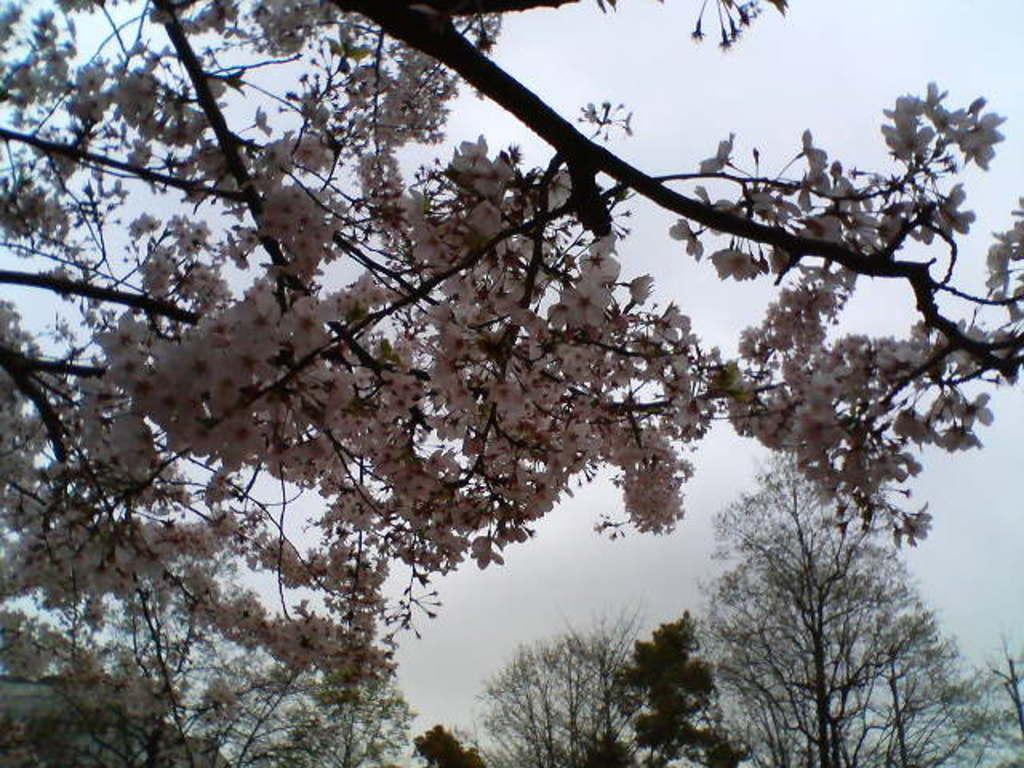What type of vegetation can be seen in the image? There are branches and trees in the image. Are there any flowers present in the image? Yes, there are flowers in the image. What can be seen in the background of the image? The sky is visible in the background of the image. Can you describe the feather that is attached to the tree in the image? There is no feather present in the image; it only features branches, flowers, trees, and the sky. What type of beast can be seen interacting with the flowers in the image? There is no beast present in the image; it only features branches, flowers, trees, and the sky. 